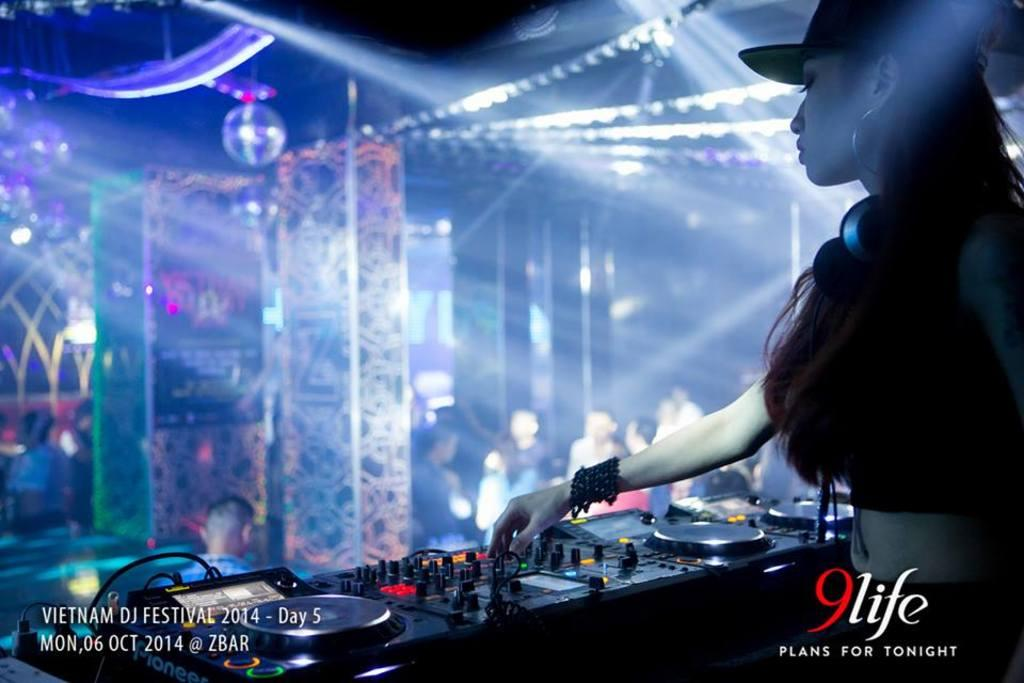What is the woman in the image doing? The woman is playing an instrument in the image. How would you describe the background of the image? The background of the image is blurred. Can you see other people in the image besides the woman playing the instrument? Yes, there are people visible in the image. What else can be seen in the image? Lights are present in the image. Where is the shop located in the image? There is no shop present in the image. Can you see a river in the image? There is no river present in the image. 